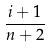<formula> <loc_0><loc_0><loc_500><loc_500>\frac { i + 1 } { n + 2 }</formula> 